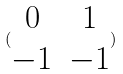<formula> <loc_0><loc_0><loc_500><loc_500>( \begin{matrix} 0 & 1 \\ - 1 & - 1 \end{matrix} )</formula> 